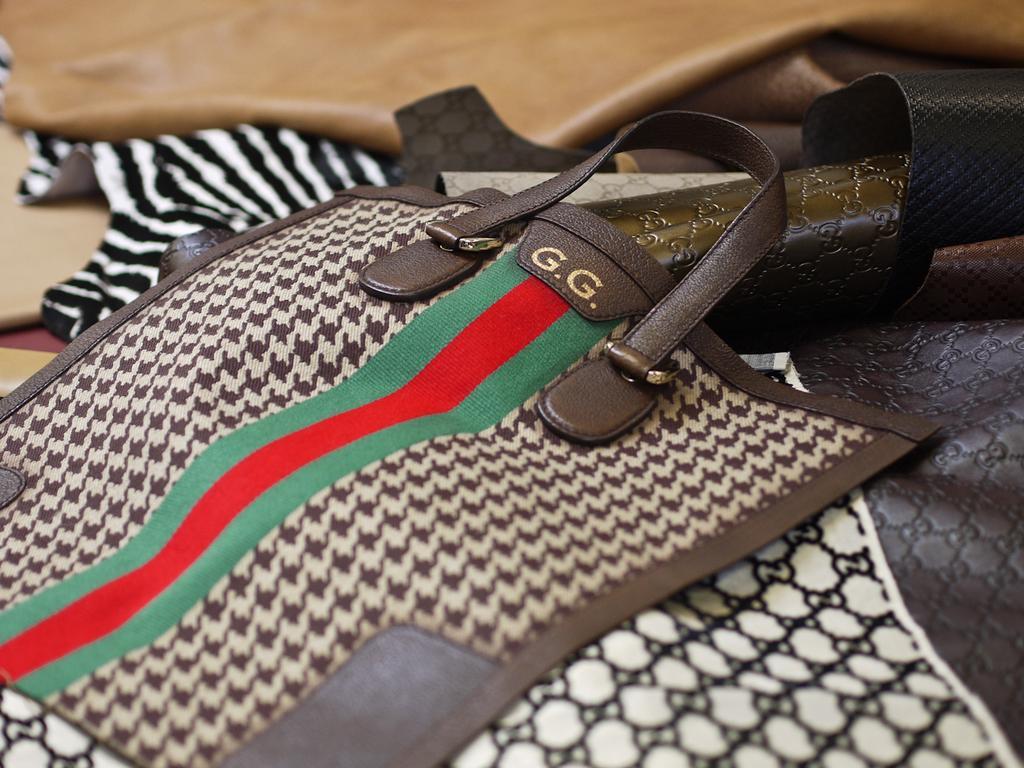Could you give a brief overview of what you see in this image? there is a bag on which g is written. 